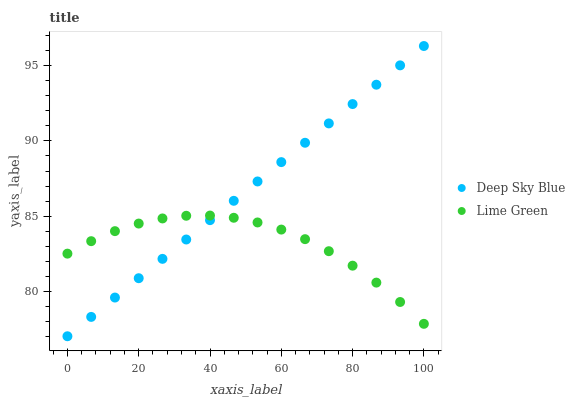Does Lime Green have the minimum area under the curve?
Answer yes or no. Yes. Does Deep Sky Blue have the maximum area under the curve?
Answer yes or no. Yes. Does Deep Sky Blue have the minimum area under the curve?
Answer yes or no. No. Is Deep Sky Blue the smoothest?
Answer yes or no. Yes. Is Lime Green the roughest?
Answer yes or no. Yes. Is Deep Sky Blue the roughest?
Answer yes or no. No. Does Deep Sky Blue have the lowest value?
Answer yes or no. Yes. Does Deep Sky Blue have the highest value?
Answer yes or no. Yes. Does Deep Sky Blue intersect Lime Green?
Answer yes or no. Yes. Is Deep Sky Blue less than Lime Green?
Answer yes or no. No. Is Deep Sky Blue greater than Lime Green?
Answer yes or no. No. 